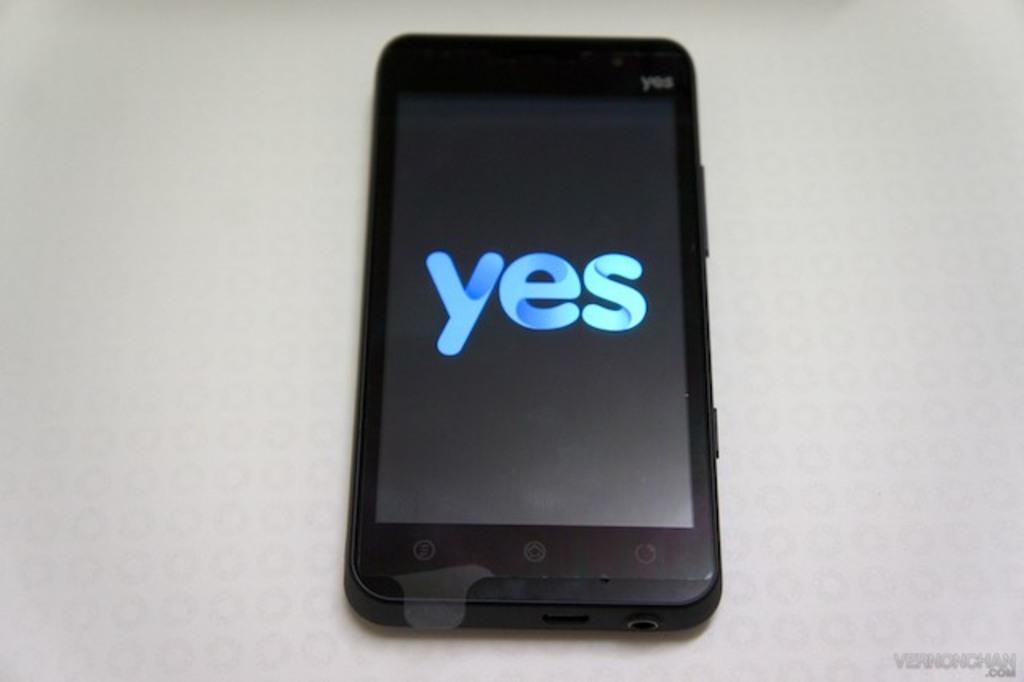Is it yes or no?
Give a very brief answer. Yes. What brand of phone is seen?
Provide a succinct answer. Yes. 